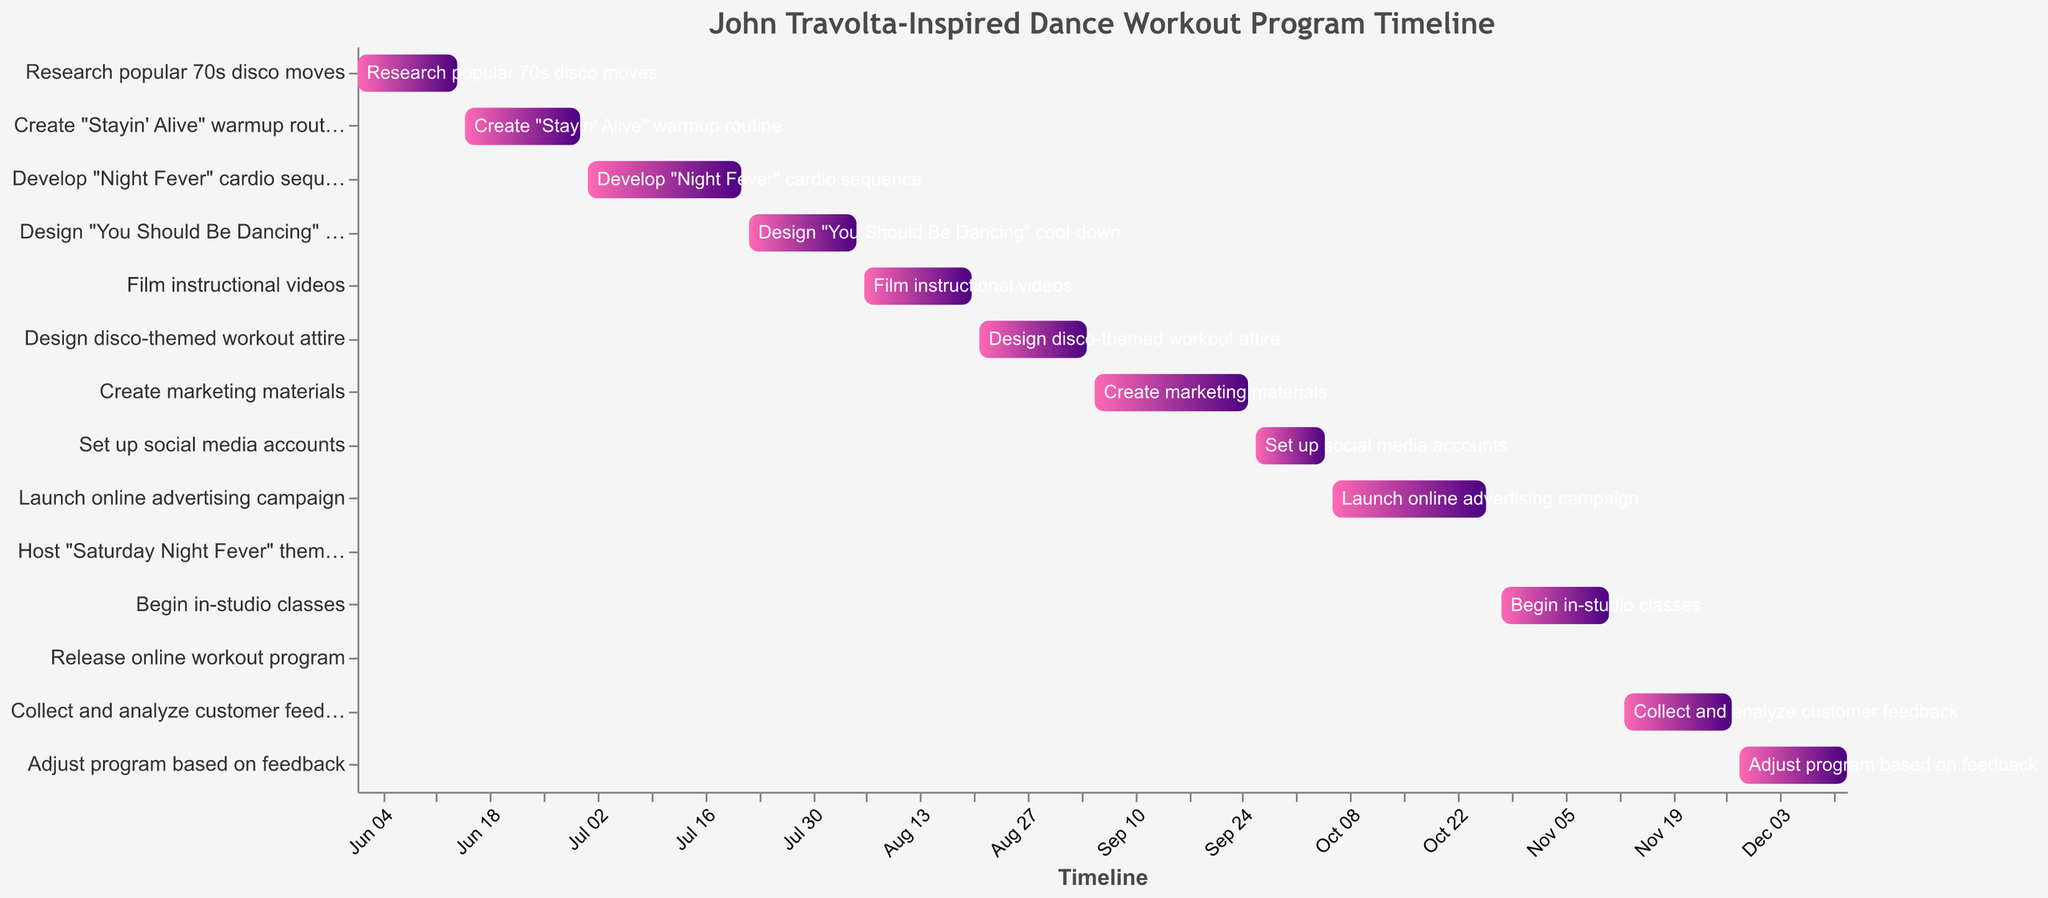What is the title of the figure? The title is usually placed at the top of the figure and is meant to provide a summary of what the figure is about.
Answer: John Travolta-Inspired Dance Workout Program Timeline What is the duration of the task "Research popular 70s disco moves"? To find the duration, subtract the start date from the end date. The start date is 2023-06-01 and the end date is 2023-06-14.
Answer: 14 days Which task has the shortest duration? Upon examining the timeline, the task "Host 'Saturday Night Fever' themed launch party" is from 2023-10-27 to 2023-10-27, making it a single day event.
Answer: Host "Saturday Night Fever" themed launch party When does the "Create marketing materials" task start and end? Refer to the timeline to locate the "Create marketing materials" task, then note the start date and end date.
Answer: Start: 2023-09-05, End: 2023-09-25 What is the total duration of the development phase? The development phase includes tasks from "Research popular 70s disco moves" to "Film instructional videos". Sum up their respective durations: 14 + 16 + 21 + 15 + 15 = 81 days.
Answer: 81 days Which task starts immediately after "Film instructional videos"? Look at the end date of "Film instructional videos" (2023-08-20) and find the task that starts right after this date.
Answer: Design disco-themed workout attire How long is the "Create 'Stayin' Alive' warmup routine" task compared to the "Develop 'Night Fever' cardio sequence"? Check the duration for both tasks: "Create 'Stayin' Alive' warmup routine" is from 2023-06-15 to 2023-06-30 (16 days), and "Develop 'Night Fever' cardio sequence" is from 2023-07-01 to 2023-07-21 (21 days). Calculate the difference.
Answer: 5 days longer What's the starting date of the final task? Identify the last task, "Adjust program based on feedback," and note its start date.
Answer: 2023-11-28 How many days are spent on creating and preparing the workout routines in total? Sum the days for "Create 'Stayin' Alive' warmup routine", "Develop 'Night Fever' cardio sequence", and "Design 'You Should Be Dancing' cool-down": 16 + 21 + 15 = 52 days.
Answer: 52 days What is the overlap between "Launch online advertising campaign" and "Host 'Saturday Night Fever' themed launch party"? "Launch online advertising campaign" ends on 2023-10-26, and "Host 'Saturday Night Fever' themed launch party" occurs on 2023-10-27. Since 2023-10-26 and 2023-10-27 are consecutive, they overlap by a single day.
Answer: 1 day 